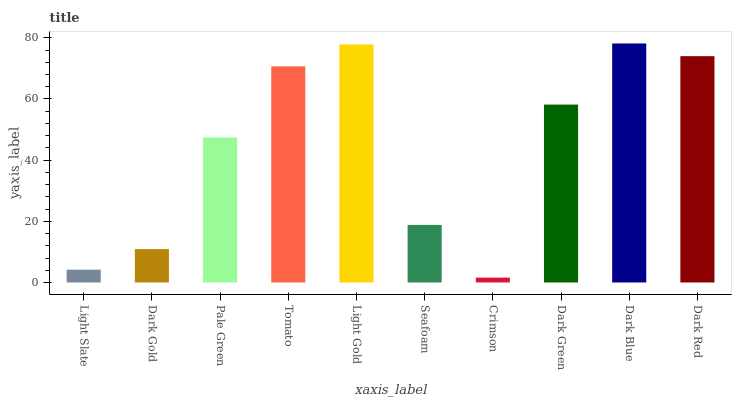Is Dark Gold the minimum?
Answer yes or no. No. Is Dark Gold the maximum?
Answer yes or no. No. Is Dark Gold greater than Light Slate?
Answer yes or no. Yes. Is Light Slate less than Dark Gold?
Answer yes or no. Yes. Is Light Slate greater than Dark Gold?
Answer yes or no. No. Is Dark Gold less than Light Slate?
Answer yes or no. No. Is Dark Green the high median?
Answer yes or no. Yes. Is Pale Green the low median?
Answer yes or no. Yes. Is Pale Green the high median?
Answer yes or no. No. Is Dark Red the low median?
Answer yes or no. No. 